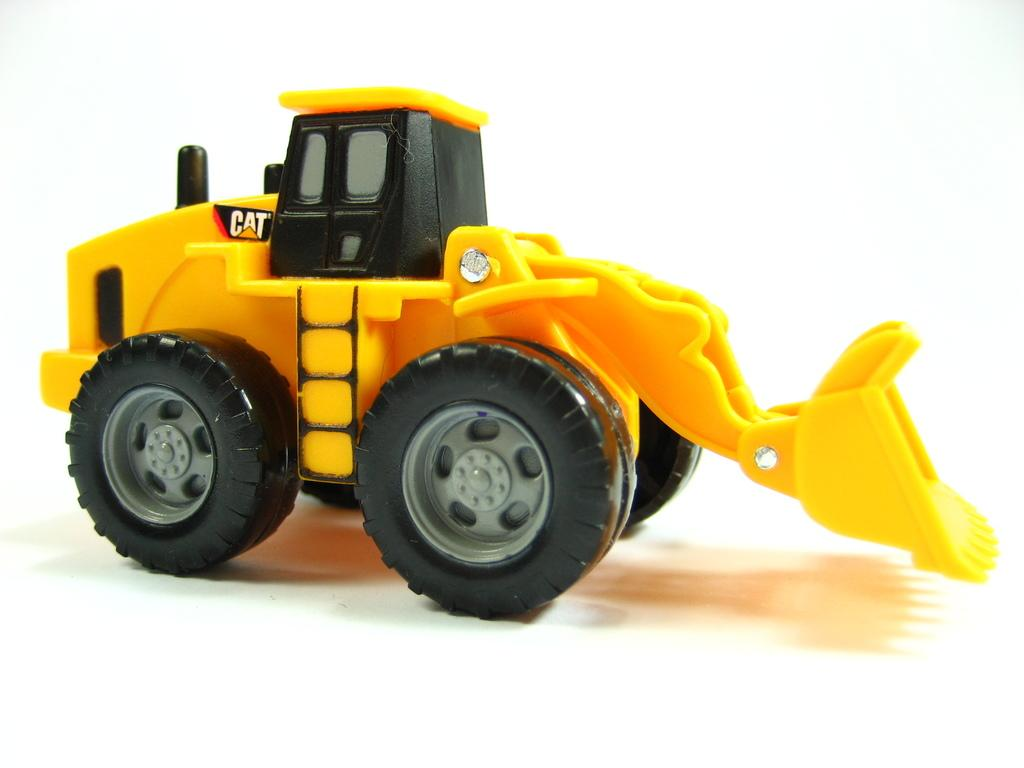What type of toy is present in the image? There is a toy excavator in the image. Can you describe the toy in more detail? The toy excavator is a small-scale replica of a real excavator, typically used for construction or digging. What is the aftermath of the cook's disgust in the image? There is no cook or any indication of disgust present in the image; it only features a toy excavator. 